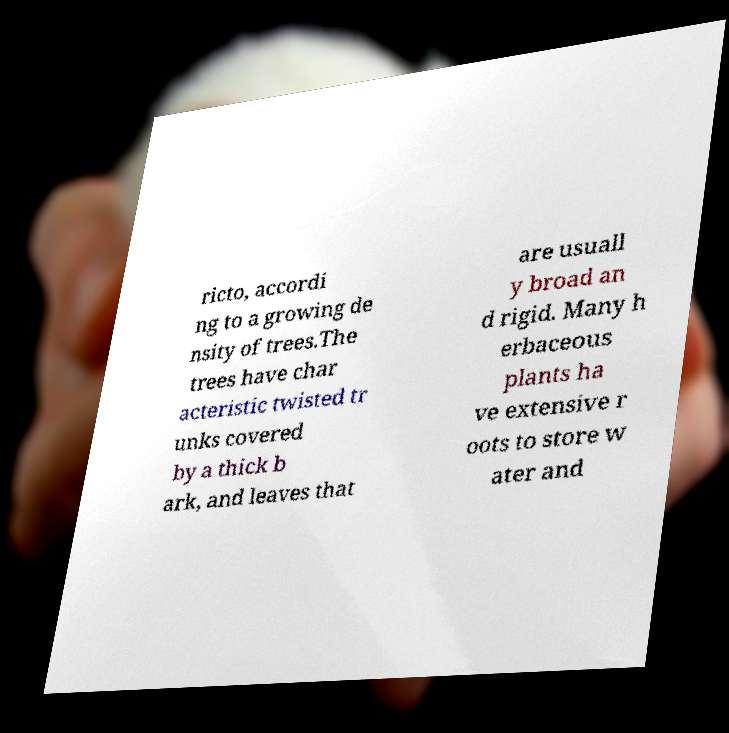Could you extract and type out the text from this image? ricto, accordi ng to a growing de nsity of trees.The trees have char acteristic twisted tr unks covered by a thick b ark, and leaves that are usuall y broad an d rigid. Many h erbaceous plants ha ve extensive r oots to store w ater and 